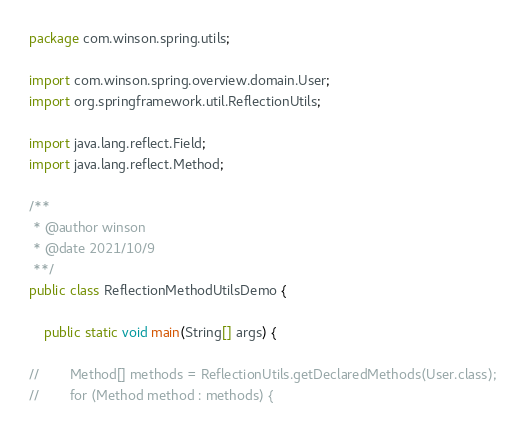<code> <loc_0><loc_0><loc_500><loc_500><_Java_>package com.winson.spring.utils;

import com.winson.spring.overview.domain.User;
import org.springframework.util.ReflectionUtils;

import java.lang.reflect.Field;
import java.lang.reflect.Method;

/**
 * @author winson
 * @date 2021/10/9
 **/
public class ReflectionMethodUtilsDemo {

    public static void main(String[] args) {

//        Method[] methods = ReflectionUtils.getDeclaredMethods(User.class);
//        for (Method method : methods) {</code> 